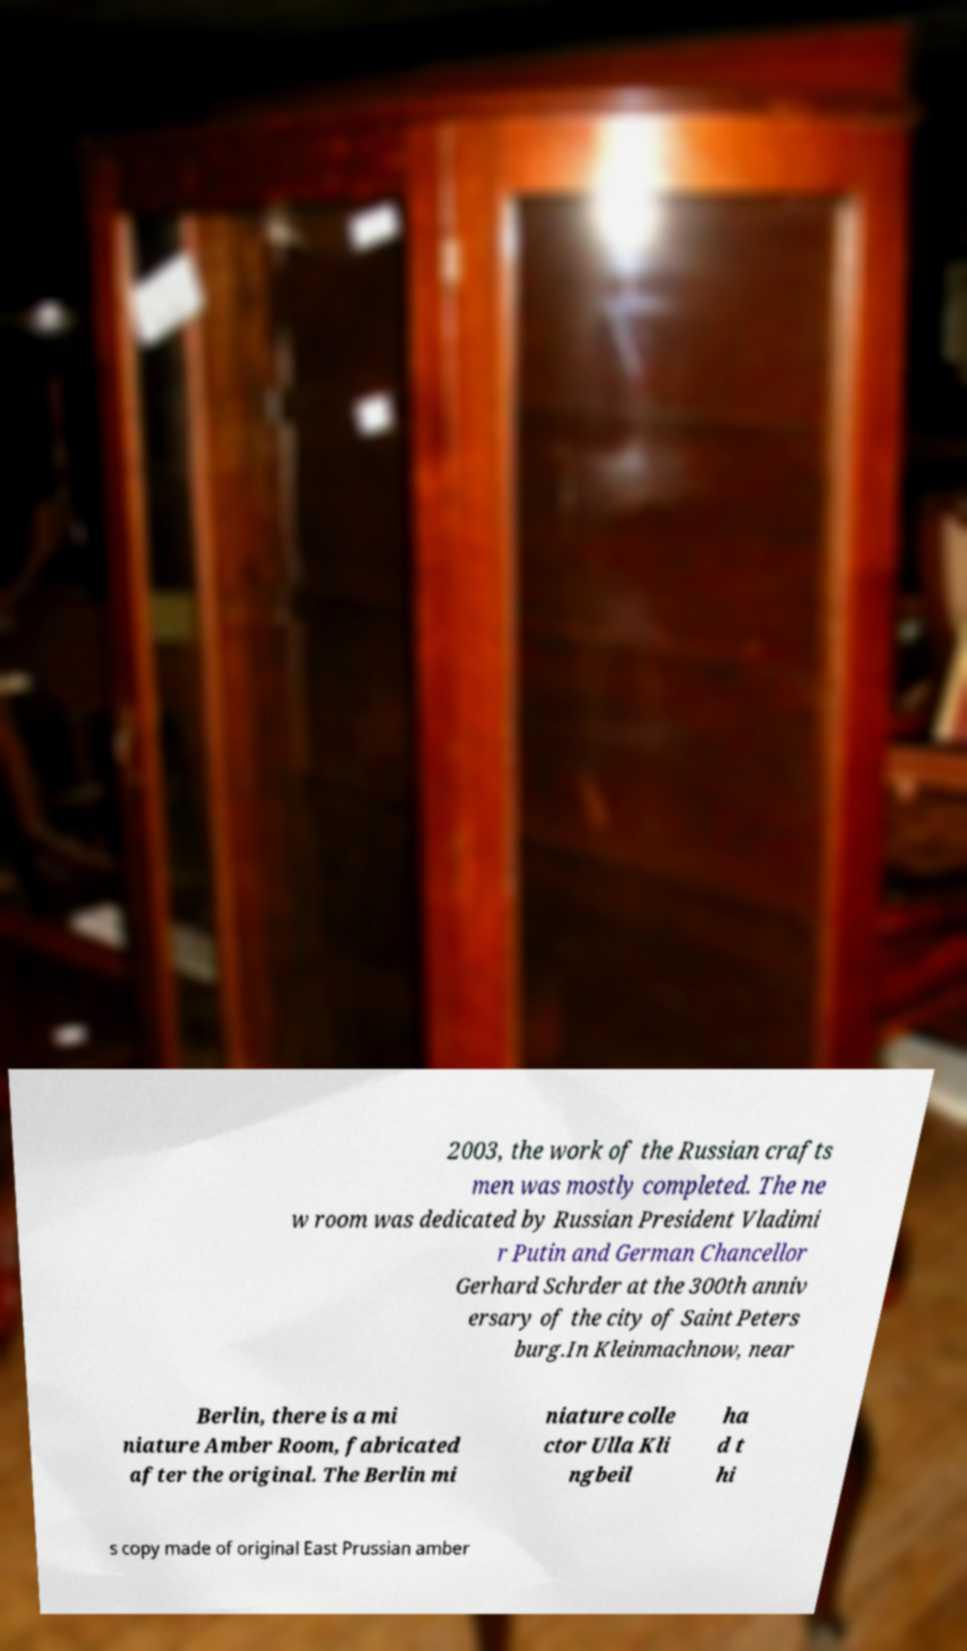Could you extract and type out the text from this image? 2003, the work of the Russian crafts men was mostly completed. The ne w room was dedicated by Russian President Vladimi r Putin and German Chancellor Gerhard Schrder at the 300th anniv ersary of the city of Saint Peters burg.In Kleinmachnow, near Berlin, there is a mi niature Amber Room, fabricated after the original. The Berlin mi niature colle ctor Ulla Kli ngbeil ha d t hi s copy made of original East Prussian amber 